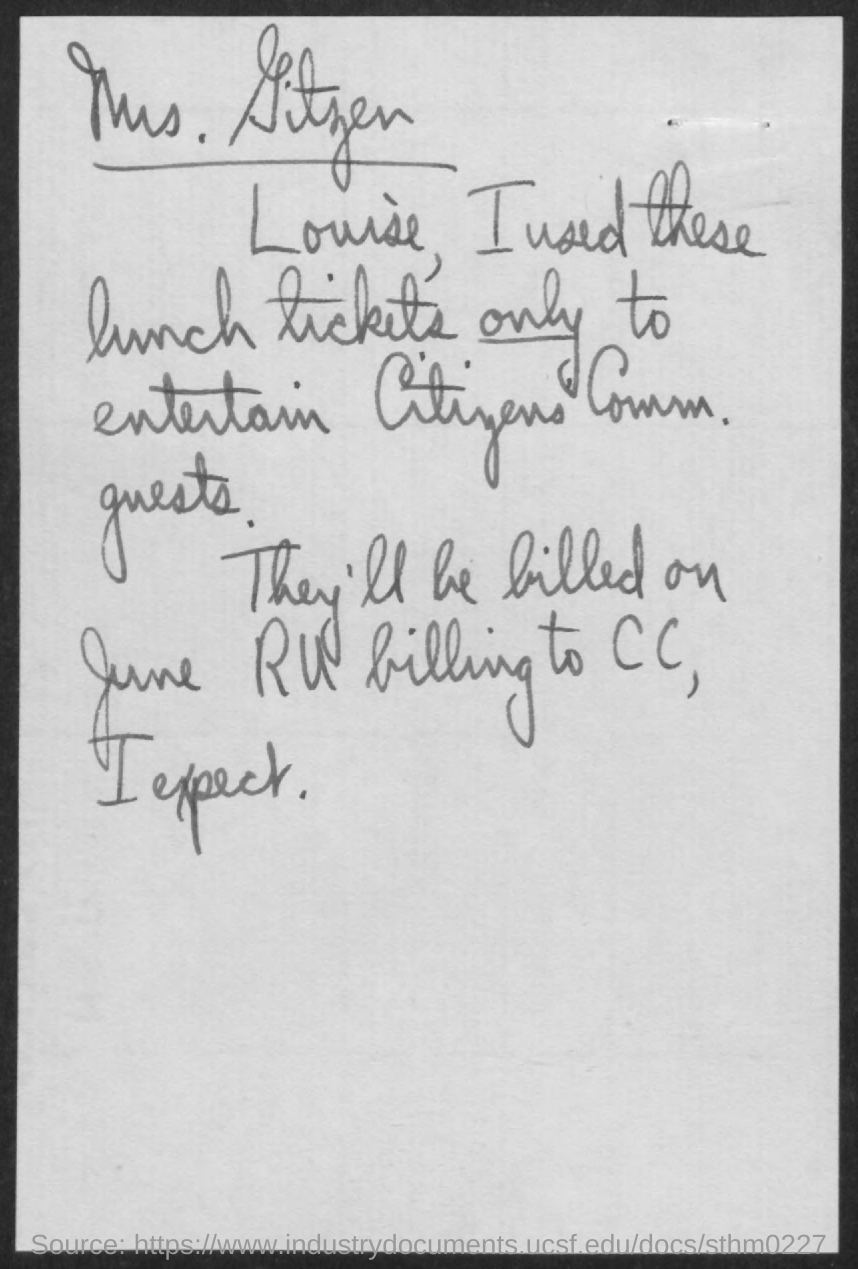Which month is mentioned in the document?
Your response must be concise. June. 